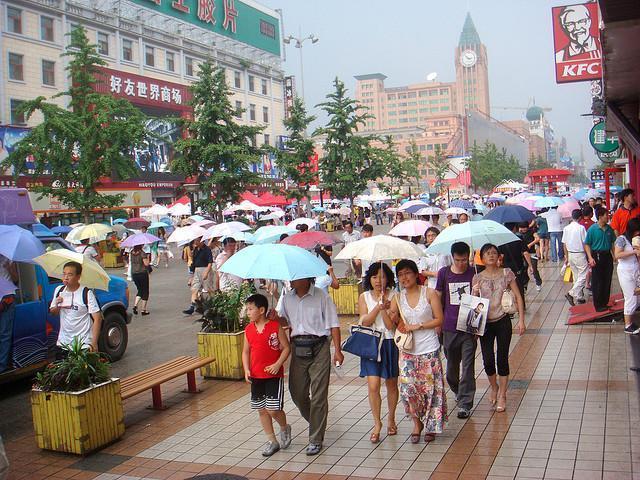How many trucks are visible?
Give a very brief answer. 2. How many umbrellas can be seen?
Give a very brief answer. 2. How many potted plants can be seen?
Give a very brief answer. 2. How many people can be seen?
Give a very brief answer. 9. How many giraffes are in the photo?
Give a very brief answer. 0. 